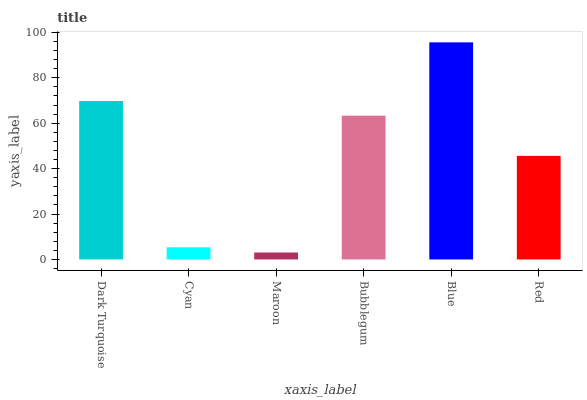Is Maroon the minimum?
Answer yes or no. Yes. Is Blue the maximum?
Answer yes or no. Yes. Is Cyan the minimum?
Answer yes or no. No. Is Cyan the maximum?
Answer yes or no. No. Is Dark Turquoise greater than Cyan?
Answer yes or no. Yes. Is Cyan less than Dark Turquoise?
Answer yes or no. Yes. Is Cyan greater than Dark Turquoise?
Answer yes or no. No. Is Dark Turquoise less than Cyan?
Answer yes or no. No. Is Bubblegum the high median?
Answer yes or no. Yes. Is Red the low median?
Answer yes or no. Yes. Is Maroon the high median?
Answer yes or no. No. Is Dark Turquoise the low median?
Answer yes or no. No. 